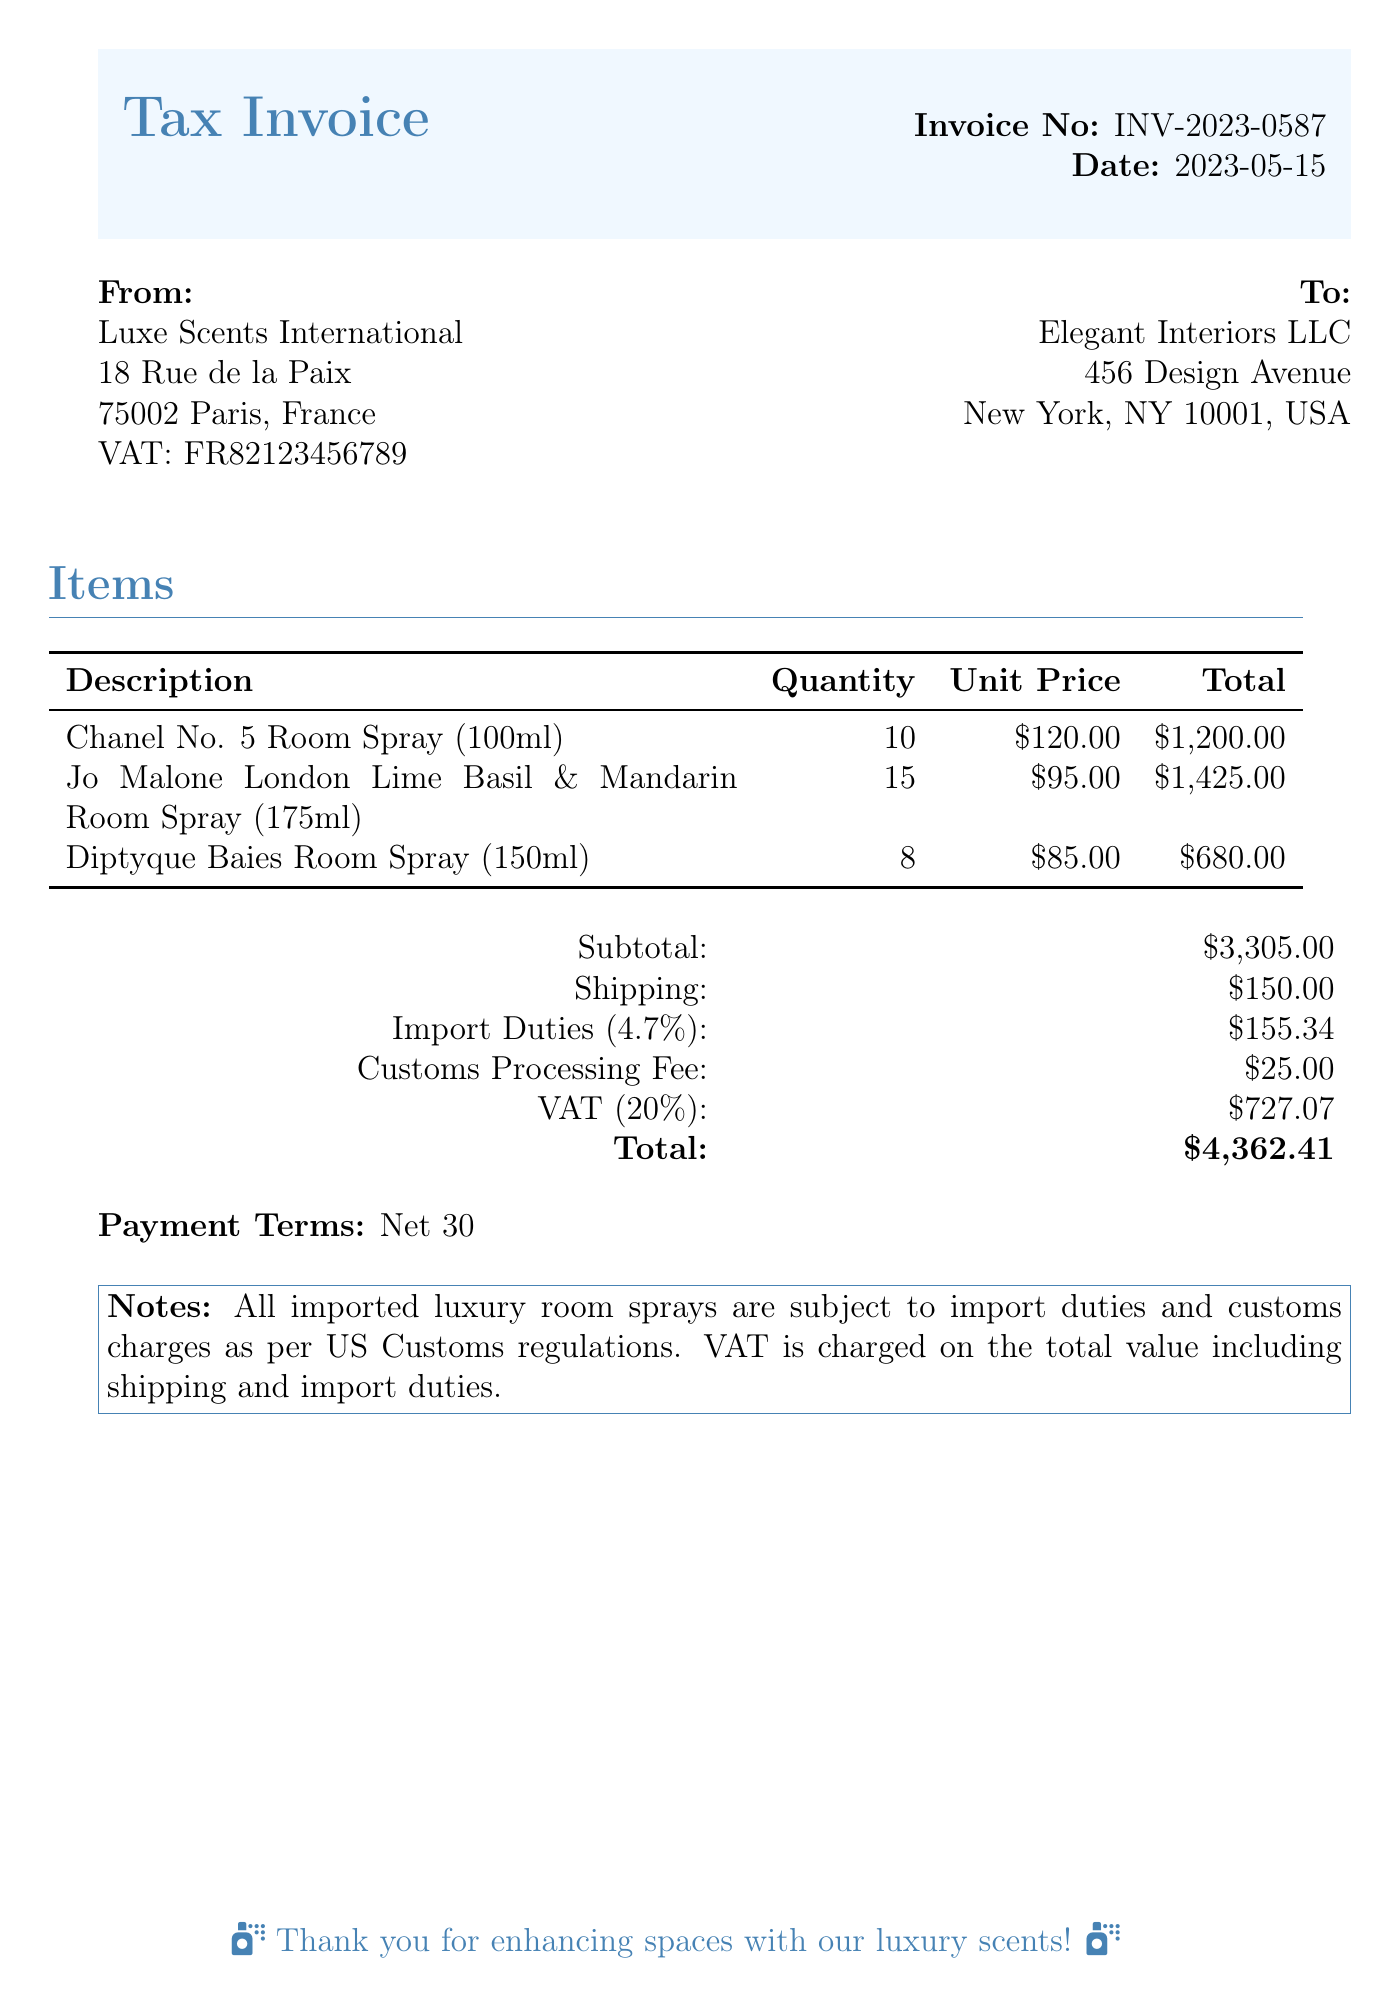What is the invoice number? The invoice number is listed in the document for identification, which is INV-2023-0587.
Answer: INV-2023-0587 What is the date of the invoice? The date of the invoice can be found in the document, which is 2023-05-15.
Answer: 2023-05-15 What is the subtotal amount? The subtotal before any other charges is detailed in the document and amounts to $3,305.00.
Answer: $3,305.00 How many Diptyque Baies Room Sprays were purchased? The document specifies the quantity purchased for each item, with 8 Diptyque Baies Room Sprays listed.
Answer: 8 What is the VAT percentage applied to the total? The document states the VAT percentage charged, which is 20%.
Answer: 20% What is the total amount to be paid? The total amount, after including all charges, is provided in the document as $4,362.41.
Answer: $4,362.41 What is the customs processing fee? The customs processing fee is listed in the document as a specific charge, which is $25.00.
Answer: $25.00 What is the shipping cost? The document lists the shipping cost, which is specified as $150.00.
Answer: $150.00 What is the total of import duties? The import duty total is explicitly stated in the document as $155.34.
Answer: $155.34 